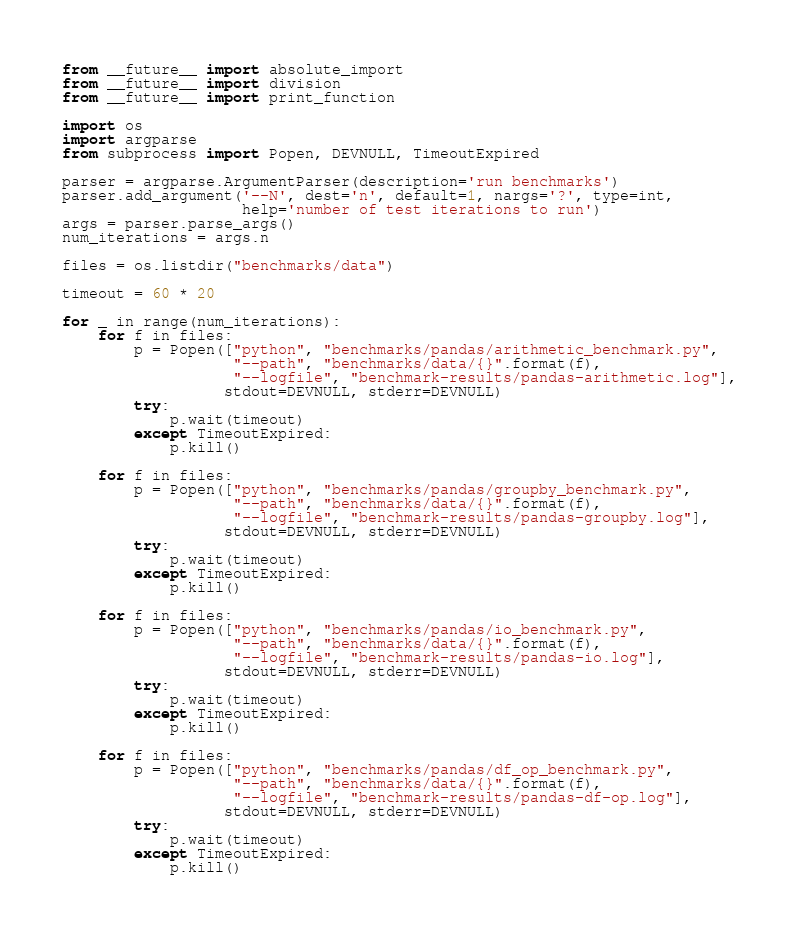Convert code to text. <code><loc_0><loc_0><loc_500><loc_500><_Python_>from __future__ import absolute_import
from __future__ import division
from __future__ import print_function

import os
import argparse
from subprocess import Popen, DEVNULL, TimeoutExpired

parser = argparse.ArgumentParser(description='run benchmarks')
parser.add_argument('--N', dest='n', default=1, nargs='?', type=int,
                    help='number of test iterations to run')
args = parser.parse_args()
num_iterations = args.n

files = os.listdir("benchmarks/data")

timeout = 60 * 20

for _ in range(num_iterations):
    for f in files:
        p = Popen(["python", "benchmarks/pandas/arithmetic_benchmark.py",
                   "--path", "benchmarks/data/{}".format(f),
                   "--logfile", "benchmark-results/pandas-arithmetic.log"],
                  stdout=DEVNULL, stderr=DEVNULL)
        try:
            p.wait(timeout)
        except TimeoutExpired:
            p.kill()

    for f in files:
        p = Popen(["python", "benchmarks/pandas/groupby_benchmark.py",
                   "--path", "benchmarks/data/{}".format(f),
                   "--logfile", "benchmark-results/pandas-groupby.log"],
                  stdout=DEVNULL, stderr=DEVNULL)
        try:
            p.wait(timeout)
        except TimeoutExpired:
            p.kill()

    for f in files:
        p = Popen(["python", "benchmarks/pandas/io_benchmark.py",
                   "--path", "benchmarks/data/{}".format(f),
                   "--logfile", "benchmark-results/pandas-io.log"],
                  stdout=DEVNULL, stderr=DEVNULL)
        try:
            p.wait(timeout)
        except TimeoutExpired:
            p.kill()

    for f in files:
        p = Popen(["python", "benchmarks/pandas/df_op_benchmark.py",
                   "--path", "benchmarks/data/{}".format(f),
                   "--logfile", "benchmark-results/pandas-df-op.log"],
                  stdout=DEVNULL, stderr=DEVNULL)
        try:
            p.wait(timeout)
        except TimeoutExpired:
            p.kill()
</code> 